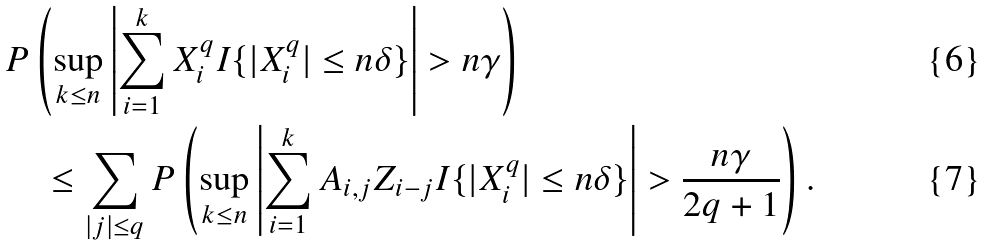<formula> <loc_0><loc_0><loc_500><loc_500>& P \left ( \sup _ { k \leq n } \left | \sum _ { i = 1 } ^ { k } X ^ { q } _ { i } I \{ | X ^ { q } _ { i } | \leq n \delta \} \right | > n \gamma \right ) \\ & \quad \leq \sum _ { | j | \leq q } P \left ( \sup _ { k \leq n } \left | \sum _ { i = 1 } ^ { k } A _ { i , j } Z _ { i - j } I \{ | X ^ { q } _ { i } | \leq n \delta \} \right | > \frac { n \gamma } { 2 q + 1 } \right ) .</formula> 